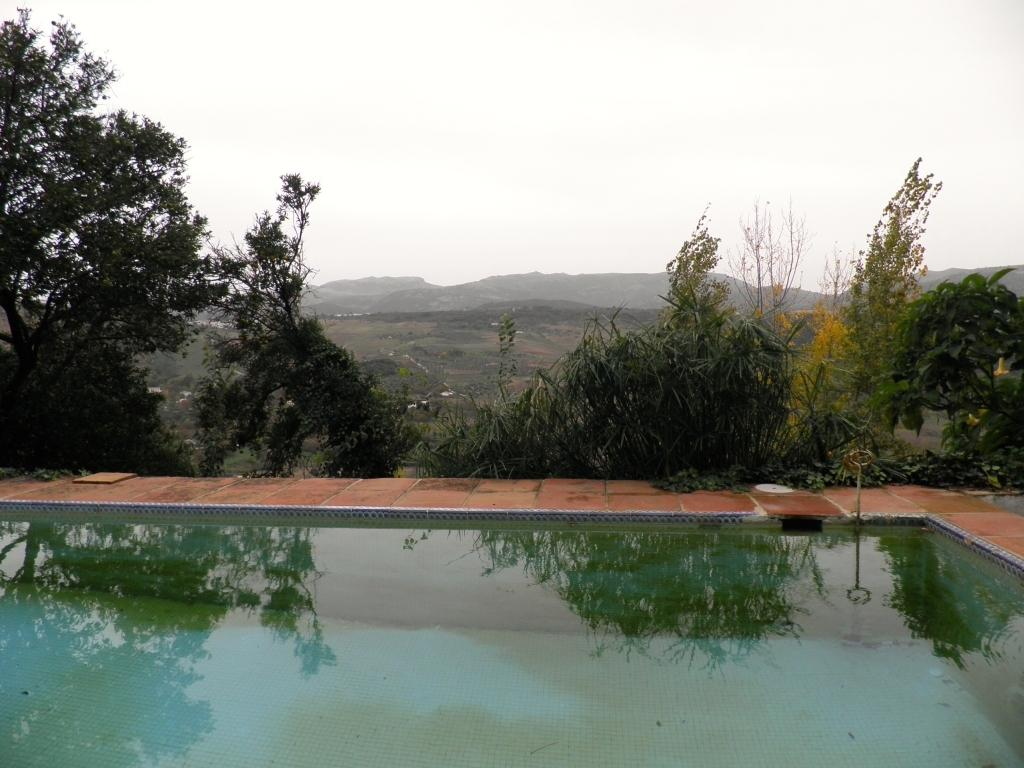What can be seen in the sky in the image? The sky is visible in the image, but no specific details about the sky are mentioned. What type of landscape feature is present in the image? There are hills in the image. What is visible at the bottom of the image? The ground is visible in the image. What type of vegetation can be seen in the image? There are trees in the image. What type of recreational feature is present in the image? There is a swimming pool in the image. What type of basin is visible in the image? There is no basin present in the image. What is the chance of rain in the image? The image does not provide any information about the weather or the chance of rain. 